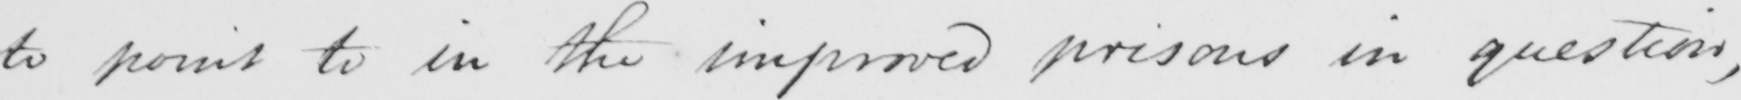Transcribe the text shown in this historical manuscript line. to point to in the improved prisons in question , 